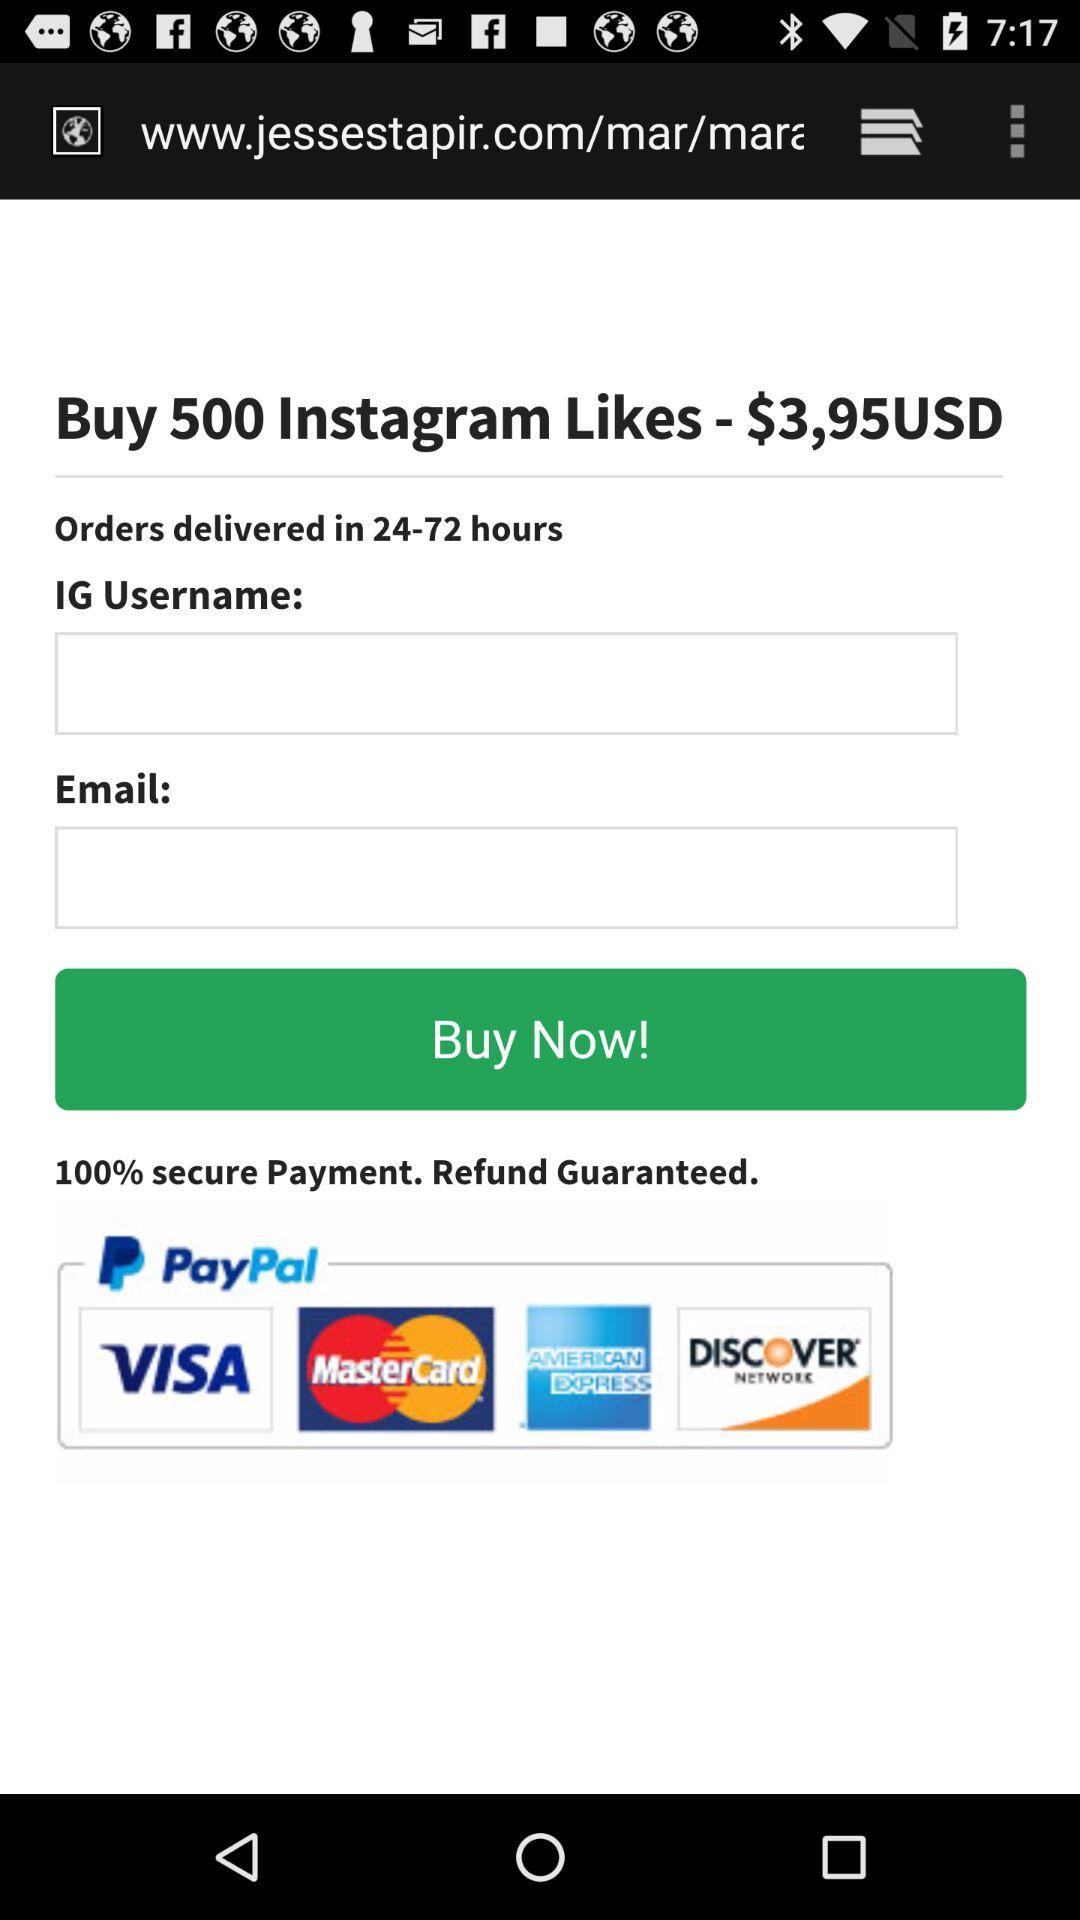What's the percentage of secure payment? The percentage is 100. 